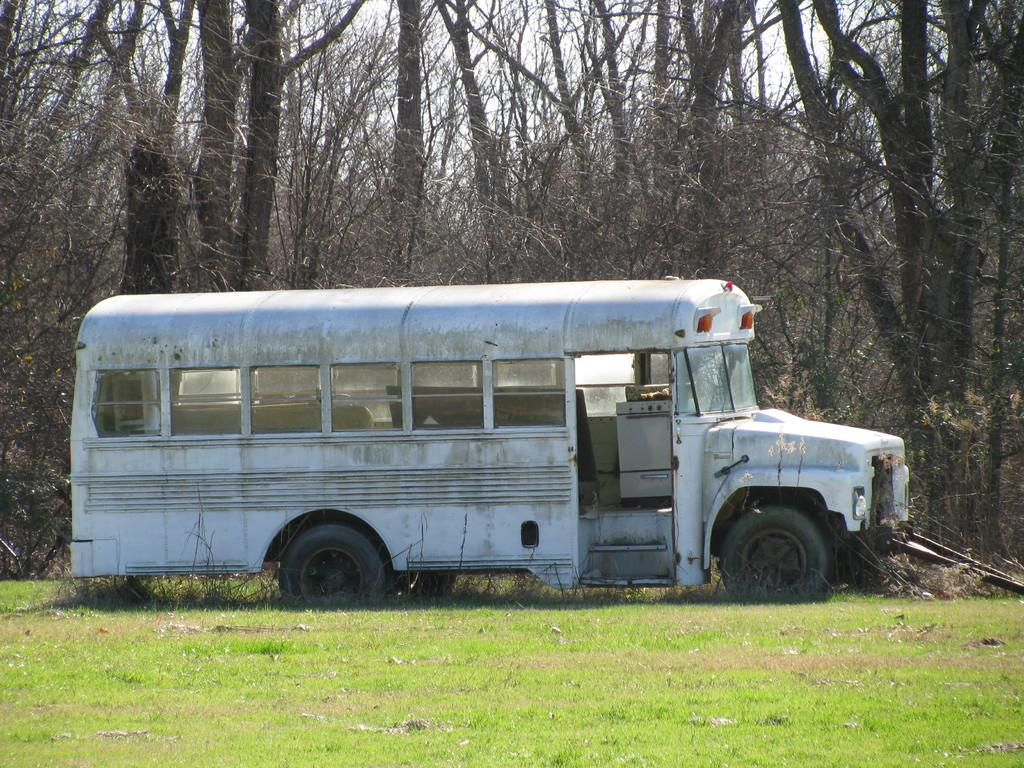What is the main subject of the image? There is a vehicle in the image. Where is the vehicle located? The vehicle is on the surface of the grass. What can be seen in the background of the image? There are trees and the sky visible in the background of the image. What type of scissors can be seen cutting the grass in the image? There are no scissors present in the image, and the grass is not being cut. 